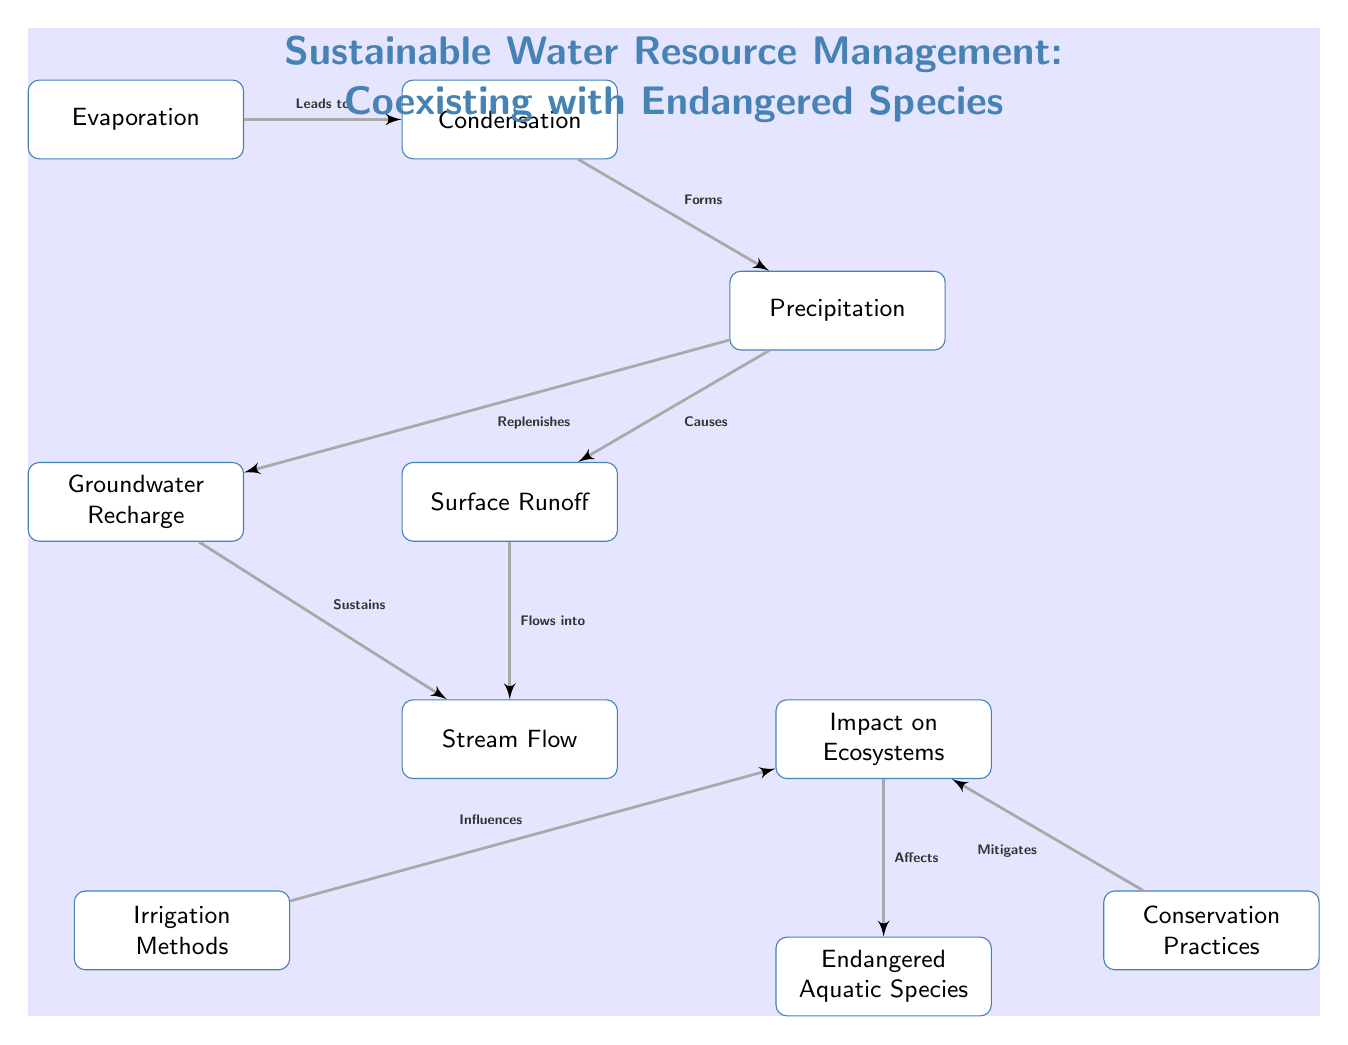What is the first step in the water cycle depicted in the diagram? The diagram shows "Evaporation" as the first node, indicating that it is the initial step in the water cycle.
Answer: Evaporation How many main processes are shown in the water cycle? The diagram includes six main processes: Evaporation, Condensation, Precipitation, Surface Runoff, Groundwater Recharge, and Stream Flow, leading to a count of six nodes representing these processes.
Answer: Six Which process leads to groundwater recharge? From the diagram, it is indicated that "Precipitation" replenishes "Groundwater Recharge," establishing a direct relationship between the two processes.
Answer: Precipitation What effect does irrigation have according to the diagram? The diagram shows that "Irrigation Methods" influence "Impact on Ecosystems," indicating that irrigation can alter ecosystem dynamics.
Answer: Influences How does conservation practices relate to the impact on ecosystems? The diagram shows that "Conservation Practices" mitigates "Impact on Ecosystems." This indicates that implementing conservation measures can reduce negative effects on local ecosystems.
Answer: Mitigates Identify the link between stream flow and groundwater in the diagram. The diagram shows that "Groundwater Recharge" sustains "Stream Flow," indicating that groundwater is essential for maintaining the flow of streams in the ecosystem.
Answer: Sustains Name one type of species affected by the impacts shown in the diagram. According to the diagram, "Endangered Aquatic Species" is directly affected by the "Impact on Ecosystems," identifying this type of species as being influenced by ecological changes.
Answer: Endangered Aquatic Species What is the relationship between surface runoff and stream flow? The diagram indicates that "Surface Runoff" flows into "Stream Flow," establishing a direct connection where runoff contributes to the flow in streams.
Answer: Flows into What process forms precipitation in the water cycle? The diagram illustrates that "Condensation" forms "Precipitation," highlighting condensation as a necessary step to produce precipitation.
Answer: Condensation 